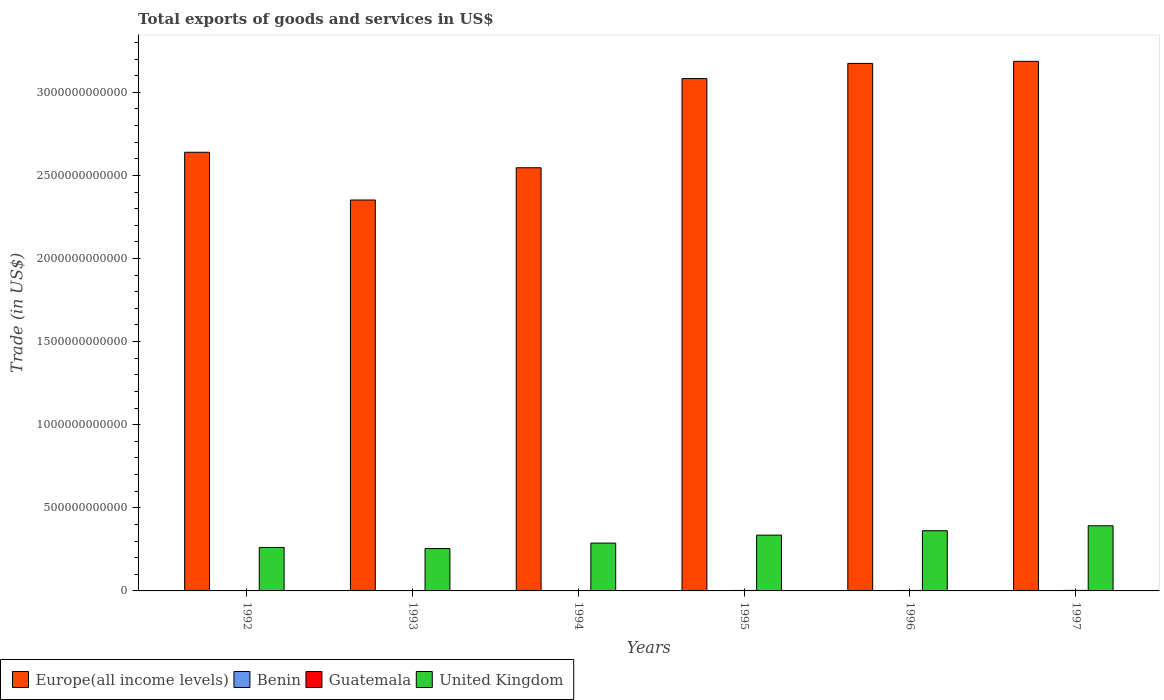How many different coloured bars are there?
Give a very brief answer. 4. How many groups of bars are there?
Provide a short and direct response. 6. Are the number of bars per tick equal to the number of legend labels?
Give a very brief answer. Yes. How many bars are there on the 4th tick from the left?
Offer a terse response. 4. How many bars are there on the 6th tick from the right?
Ensure brevity in your answer.  4. What is the label of the 6th group of bars from the left?
Ensure brevity in your answer.  1997. In how many cases, is the number of bars for a given year not equal to the number of legend labels?
Your response must be concise. 0. What is the total exports of goods and services in United Kingdom in 1995?
Your answer should be very brief. 3.36e+11. Across all years, what is the maximum total exports of goods and services in Benin?
Make the answer very short. 6.26e+08. Across all years, what is the minimum total exports of goods and services in United Kingdom?
Your answer should be compact. 2.55e+11. What is the total total exports of goods and services in Benin in the graph?
Your answer should be compact. 3.19e+09. What is the difference between the total exports of goods and services in Guatemala in 1992 and that in 1994?
Your answer should be very brief. -3.88e+08. What is the difference between the total exports of goods and services in Guatemala in 1993 and the total exports of goods and services in United Kingdom in 1995?
Ensure brevity in your answer.  -3.34e+11. What is the average total exports of goods and services in Europe(all income levels) per year?
Ensure brevity in your answer.  2.83e+12. In the year 1996, what is the difference between the total exports of goods and services in United Kingdom and total exports of goods and services in Europe(all income levels)?
Make the answer very short. -2.81e+12. What is the ratio of the total exports of goods and services in United Kingdom in 1992 to that in 1996?
Offer a terse response. 0.72. Is the total exports of goods and services in Benin in 1995 less than that in 1997?
Keep it short and to the point. Yes. Is the difference between the total exports of goods and services in United Kingdom in 1992 and 1997 greater than the difference between the total exports of goods and services in Europe(all income levels) in 1992 and 1997?
Provide a short and direct response. Yes. What is the difference between the highest and the second highest total exports of goods and services in Benin?
Provide a succinct answer. 9.23e+06. What is the difference between the highest and the lowest total exports of goods and services in Benin?
Provide a short and direct response. 2.32e+08. In how many years, is the total exports of goods and services in Guatemala greater than the average total exports of goods and services in Guatemala taken over all years?
Keep it short and to the point. 3. Is the sum of the total exports of goods and services in Europe(all income levels) in 1992 and 1996 greater than the maximum total exports of goods and services in Benin across all years?
Offer a terse response. Yes. Is it the case that in every year, the sum of the total exports of goods and services in Europe(all income levels) and total exports of goods and services in United Kingdom is greater than the sum of total exports of goods and services in Guatemala and total exports of goods and services in Benin?
Your response must be concise. No. What does the 1st bar from the left in 1992 represents?
Offer a very short reply. Europe(all income levels). What does the 4th bar from the right in 1995 represents?
Provide a succinct answer. Europe(all income levels). Are all the bars in the graph horizontal?
Offer a terse response. No. What is the difference between two consecutive major ticks on the Y-axis?
Provide a short and direct response. 5.00e+11. Does the graph contain any zero values?
Offer a very short reply. No. Where does the legend appear in the graph?
Offer a very short reply. Bottom left. How many legend labels are there?
Give a very brief answer. 4. How are the legend labels stacked?
Keep it short and to the point. Horizontal. What is the title of the graph?
Provide a succinct answer. Total exports of goods and services in US$. What is the label or title of the X-axis?
Provide a short and direct response. Years. What is the label or title of the Y-axis?
Offer a very short reply. Trade (in US$). What is the Trade (in US$) of Europe(all income levels) in 1992?
Offer a very short reply. 2.64e+12. What is the Trade (in US$) in Benin in 1992?
Your answer should be very brief. 3.94e+08. What is the Trade (in US$) in Guatemala in 1992?
Provide a succinct answer. 1.89e+09. What is the Trade (in US$) of United Kingdom in 1992?
Your answer should be very brief. 2.62e+11. What is the Trade (in US$) in Europe(all income levels) in 1993?
Provide a succinct answer. 2.35e+12. What is the Trade (in US$) of Benin in 1993?
Provide a short and direct response. 5.11e+08. What is the Trade (in US$) in Guatemala in 1993?
Keep it short and to the point. 2.02e+09. What is the Trade (in US$) in United Kingdom in 1993?
Keep it short and to the point. 2.55e+11. What is the Trade (in US$) of Europe(all income levels) in 1994?
Ensure brevity in your answer.  2.55e+12. What is the Trade (in US$) in Benin in 1994?
Provide a short and direct response. 4.53e+08. What is the Trade (in US$) in Guatemala in 1994?
Give a very brief answer. 2.27e+09. What is the Trade (in US$) of United Kingdom in 1994?
Ensure brevity in your answer.  2.88e+11. What is the Trade (in US$) in Europe(all income levels) in 1995?
Offer a very short reply. 3.08e+12. What is the Trade (in US$) in Benin in 1995?
Give a very brief answer. 5.94e+08. What is the Trade (in US$) in Guatemala in 1995?
Make the answer very short. 2.82e+09. What is the Trade (in US$) in United Kingdom in 1995?
Your answer should be very brief. 3.36e+11. What is the Trade (in US$) in Europe(all income levels) in 1996?
Your answer should be very brief. 3.17e+12. What is the Trade (in US$) in Benin in 1996?
Keep it short and to the point. 6.26e+08. What is the Trade (in US$) of Guatemala in 1996?
Your response must be concise. 2.81e+09. What is the Trade (in US$) of United Kingdom in 1996?
Give a very brief answer. 3.62e+11. What is the Trade (in US$) in Europe(all income levels) in 1997?
Offer a very short reply. 3.19e+12. What is the Trade (in US$) in Benin in 1997?
Your answer should be compact. 6.16e+08. What is the Trade (in US$) in Guatemala in 1997?
Make the answer very short. 3.19e+09. What is the Trade (in US$) in United Kingdom in 1997?
Your response must be concise. 3.92e+11. Across all years, what is the maximum Trade (in US$) of Europe(all income levels)?
Keep it short and to the point. 3.19e+12. Across all years, what is the maximum Trade (in US$) of Benin?
Make the answer very short. 6.26e+08. Across all years, what is the maximum Trade (in US$) of Guatemala?
Your answer should be compact. 3.19e+09. Across all years, what is the maximum Trade (in US$) in United Kingdom?
Your answer should be very brief. 3.92e+11. Across all years, what is the minimum Trade (in US$) of Europe(all income levels)?
Your response must be concise. 2.35e+12. Across all years, what is the minimum Trade (in US$) of Benin?
Your answer should be very brief. 3.94e+08. Across all years, what is the minimum Trade (in US$) in Guatemala?
Keep it short and to the point. 1.89e+09. Across all years, what is the minimum Trade (in US$) in United Kingdom?
Your answer should be compact. 2.55e+11. What is the total Trade (in US$) of Europe(all income levels) in the graph?
Offer a very short reply. 1.70e+13. What is the total Trade (in US$) in Benin in the graph?
Provide a succinct answer. 3.19e+09. What is the total Trade (in US$) in Guatemala in the graph?
Offer a terse response. 1.50e+1. What is the total Trade (in US$) in United Kingdom in the graph?
Offer a very short reply. 1.89e+12. What is the difference between the Trade (in US$) in Europe(all income levels) in 1992 and that in 1993?
Provide a short and direct response. 2.87e+11. What is the difference between the Trade (in US$) of Benin in 1992 and that in 1993?
Keep it short and to the point. -1.17e+08. What is the difference between the Trade (in US$) in Guatemala in 1992 and that in 1993?
Give a very brief answer. -1.32e+08. What is the difference between the Trade (in US$) of United Kingdom in 1992 and that in 1993?
Offer a terse response. 6.63e+09. What is the difference between the Trade (in US$) of Europe(all income levels) in 1992 and that in 1994?
Ensure brevity in your answer.  9.32e+1. What is the difference between the Trade (in US$) of Benin in 1992 and that in 1994?
Offer a very short reply. -5.87e+07. What is the difference between the Trade (in US$) in Guatemala in 1992 and that in 1994?
Your answer should be compact. -3.88e+08. What is the difference between the Trade (in US$) of United Kingdom in 1992 and that in 1994?
Give a very brief answer. -2.61e+1. What is the difference between the Trade (in US$) of Europe(all income levels) in 1992 and that in 1995?
Your answer should be very brief. -4.43e+11. What is the difference between the Trade (in US$) in Benin in 1992 and that in 1995?
Your answer should be very brief. -2.00e+08. What is the difference between the Trade (in US$) of Guatemala in 1992 and that in 1995?
Make the answer very short. -9.37e+08. What is the difference between the Trade (in US$) in United Kingdom in 1992 and that in 1995?
Your response must be concise. -7.41e+1. What is the difference between the Trade (in US$) in Europe(all income levels) in 1992 and that in 1996?
Make the answer very short. -5.35e+11. What is the difference between the Trade (in US$) in Benin in 1992 and that in 1996?
Offer a terse response. -2.32e+08. What is the difference between the Trade (in US$) of Guatemala in 1992 and that in 1996?
Keep it short and to the point. -9.24e+08. What is the difference between the Trade (in US$) of United Kingdom in 1992 and that in 1996?
Your answer should be compact. -1.01e+11. What is the difference between the Trade (in US$) of Europe(all income levels) in 1992 and that in 1997?
Ensure brevity in your answer.  -5.47e+11. What is the difference between the Trade (in US$) in Benin in 1992 and that in 1997?
Provide a succinct answer. -2.22e+08. What is the difference between the Trade (in US$) in Guatemala in 1992 and that in 1997?
Ensure brevity in your answer.  -1.31e+09. What is the difference between the Trade (in US$) in United Kingdom in 1992 and that in 1997?
Your answer should be compact. -1.30e+11. What is the difference between the Trade (in US$) of Europe(all income levels) in 1993 and that in 1994?
Ensure brevity in your answer.  -1.94e+11. What is the difference between the Trade (in US$) in Benin in 1993 and that in 1994?
Provide a succinct answer. 5.83e+07. What is the difference between the Trade (in US$) of Guatemala in 1993 and that in 1994?
Offer a terse response. -2.57e+08. What is the difference between the Trade (in US$) of United Kingdom in 1993 and that in 1994?
Your answer should be compact. -3.27e+1. What is the difference between the Trade (in US$) in Europe(all income levels) in 1993 and that in 1995?
Give a very brief answer. -7.31e+11. What is the difference between the Trade (in US$) of Benin in 1993 and that in 1995?
Make the answer very short. -8.28e+07. What is the difference between the Trade (in US$) in Guatemala in 1993 and that in 1995?
Ensure brevity in your answer.  -8.05e+08. What is the difference between the Trade (in US$) of United Kingdom in 1993 and that in 1995?
Provide a short and direct response. -8.07e+1. What is the difference between the Trade (in US$) of Europe(all income levels) in 1993 and that in 1996?
Ensure brevity in your answer.  -8.22e+11. What is the difference between the Trade (in US$) of Benin in 1993 and that in 1996?
Your answer should be very brief. -1.15e+08. What is the difference between the Trade (in US$) of Guatemala in 1993 and that in 1996?
Ensure brevity in your answer.  -7.93e+08. What is the difference between the Trade (in US$) of United Kingdom in 1993 and that in 1996?
Your answer should be very brief. -1.07e+11. What is the difference between the Trade (in US$) of Europe(all income levels) in 1993 and that in 1997?
Your response must be concise. -8.34e+11. What is the difference between the Trade (in US$) of Benin in 1993 and that in 1997?
Offer a very short reply. -1.05e+08. What is the difference between the Trade (in US$) of Guatemala in 1993 and that in 1997?
Provide a short and direct response. -1.18e+09. What is the difference between the Trade (in US$) of United Kingdom in 1993 and that in 1997?
Your answer should be compact. -1.37e+11. What is the difference between the Trade (in US$) in Europe(all income levels) in 1994 and that in 1995?
Provide a short and direct response. -5.37e+11. What is the difference between the Trade (in US$) of Benin in 1994 and that in 1995?
Provide a short and direct response. -1.41e+08. What is the difference between the Trade (in US$) in Guatemala in 1994 and that in 1995?
Make the answer very short. -5.48e+08. What is the difference between the Trade (in US$) of United Kingdom in 1994 and that in 1995?
Make the answer very short. -4.80e+1. What is the difference between the Trade (in US$) of Europe(all income levels) in 1994 and that in 1996?
Your answer should be compact. -6.28e+11. What is the difference between the Trade (in US$) in Benin in 1994 and that in 1996?
Offer a very short reply. -1.73e+08. What is the difference between the Trade (in US$) in Guatemala in 1994 and that in 1996?
Provide a short and direct response. -5.36e+08. What is the difference between the Trade (in US$) of United Kingdom in 1994 and that in 1996?
Your answer should be compact. -7.46e+1. What is the difference between the Trade (in US$) of Europe(all income levels) in 1994 and that in 1997?
Offer a very short reply. -6.40e+11. What is the difference between the Trade (in US$) in Benin in 1994 and that in 1997?
Your answer should be very brief. -1.64e+08. What is the difference between the Trade (in US$) of Guatemala in 1994 and that in 1997?
Provide a short and direct response. -9.19e+08. What is the difference between the Trade (in US$) of United Kingdom in 1994 and that in 1997?
Keep it short and to the point. -1.04e+11. What is the difference between the Trade (in US$) of Europe(all income levels) in 1995 and that in 1996?
Ensure brevity in your answer.  -9.12e+1. What is the difference between the Trade (in US$) of Benin in 1995 and that in 1996?
Offer a very short reply. -3.19e+07. What is the difference between the Trade (in US$) in Guatemala in 1995 and that in 1996?
Your response must be concise. 1.21e+07. What is the difference between the Trade (in US$) of United Kingdom in 1995 and that in 1996?
Ensure brevity in your answer.  -2.66e+1. What is the difference between the Trade (in US$) of Europe(all income levels) in 1995 and that in 1997?
Provide a succinct answer. -1.04e+11. What is the difference between the Trade (in US$) in Benin in 1995 and that in 1997?
Offer a very short reply. -2.26e+07. What is the difference between the Trade (in US$) in Guatemala in 1995 and that in 1997?
Your answer should be very brief. -3.71e+08. What is the difference between the Trade (in US$) of United Kingdom in 1995 and that in 1997?
Your response must be concise. -5.63e+1. What is the difference between the Trade (in US$) of Europe(all income levels) in 1996 and that in 1997?
Make the answer very short. -1.24e+1. What is the difference between the Trade (in US$) in Benin in 1996 and that in 1997?
Offer a terse response. 9.23e+06. What is the difference between the Trade (in US$) in Guatemala in 1996 and that in 1997?
Provide a short and direct response. -3.83e+08. What is the difference between the Trade (in US$) of United Kingdom in 1996 and that in 1997?
Keep it short and to the point. -2.97e+1. What is the difference between the Trade (in US$) of Europe(all income levels) in 1992 and the Trade (in US$) of Benin in 1993?
Make the answer very short. 2.64e+12. What is the difference between the Trade (in US$) in Europe(all income levels) in 1992 and the Trade (in US$) in Guatemala in 1993?
Your answer should be very brief. 2.64e+12. What is the difference between the Trade (in US$) of Europe(all income levels) in 1992 and the Trade (in US$) of United Kingdom in 1993?
Offer a very short reply. 2.38e+12. What is the difference between the Trade (in US$) of Benin in 1992 and the Trade (in US$) of Guatemala in 1993?
Give a very brief answer. -1.62e+09. What is the difference between the Trade (in US$) of Benin in 1992 and the Trade (in US$) of United Kingdom in 1993?
Keep it short and to the point. -2.55e+11. What is the difference between the Trade (in US$) of Guatemala in 1992 and the Trade (in US$) of United Kingdom in 1993?
Your answer should be very brief. -2.53e+11. What is the difference between the Trade (in US$) in Europe(all income levels) in 1992 and the Trade (in US$) in Benin in 1994?
Make the answer very short. 2.64e+12. What is the difference between the Trade (in US$) of Europe(all income levels) in 1992 and the Trade (in US$) of Guatemala in 1994?
Make the answer very short. 2.64e+12. What is the difference between the Trade (in US$) in Europe(all income levels) in 1992 and the Trade (in US$) in United Kingdom in 1994?
Give a very brief answer. 2.35e+12. What is the difference between the Trade (in US$) of Benin in 1992 and the Trade (in US$) of Guatemala in 1994?
Offer a very short reply. -1.88e+09. What is the difference between the Trade (in US$) in Benin in 1992 and the Trade (in US$) in United Kingdom in 1994?
Keep it short and to the point. -2.87e+11. What is the difference between the Trade (in US$) of Guatemala in 1992 and the Trade (in US$) of United Kingdom in 1994?
Make the answer very short. -2.86e+11. What is the difference between the Trade (in US$) in Europe(all income levels) in 1992 and the Trade (in US$) in Benin in 1995?
Provide a short and direct response. 2.64e+12. What is the difference between the Trade (in US$) in Europe(all income levels) in 1992 and the Trade (in US$) in Guatemala in 1995?
Offer a terse response. 2.64e+12. What is the difference between the Trade (in US$) of Europe(all income levels) in 1992 and the Trade (in US$) of United Kingdom in 1995?
Your answer should be compact. 2.30e+12. What is the difference between the Trade (in US$) of Benin in 1992 and the Trade (in US$) of Guatemala in 1995?
Your answer should be very brief. -2.43e+09. What is the difference between the Trade (in US$) in Benin in 1992 and the Trade (in US$) in United Kingdom in 1995?
Offer a very short reply. -3.35e+11. What is the difference between the Trade (in US$) in Guatemala in 1992 and the Trade (in US$) in United Kingdom in 1995?
Provide a succinct answer. -3.34e+11. What is the difference between the Trade (in US$) of Europe(all income levels) in 1992 and the Trade (in US$) of Benin in 1996?
Give a very brief answer. 2.64e+12. What is the difference between the Trade (in US$) of Europe(all income levels) in 1992 and the Trade (in US$) of Guatemala in 1996?
Offer a terse response. 2.64e+12. What is the difference between the Trade (in US$) in Europe(all income levels) in 1992 and the Trade (in US$) in United Kingdom in 1996?
Your answer should be compact. 2.28e+12. What is the difference between the Trade (in US$) in Benin in 1992 and the Trade (in US$) in Guatemala in 1996?
Make the answer very short. -2.42e+09. What is the difference between the Trade (in US$) in Benin in 1992 and the Trade (in US$) in United Kingdom in 1996?
Make the answer very short. -3.62e+11. What is the difference between the Trade (in US$) in Guatemala in 1992 and the Trade (in US$) in United Kingdom in 1996?
Provide a succinct answer. -3.60e+11. What is the difference between the Trade (in US$) of Europe(all income levels) in 1992 and the Trade (in US$) of Benin in 1997?
Provide a succinct answer. 2.64e+12. What is the difference between the Trade (in US$) of Europe(all income levels) in 1992 and the Trade (in US$) of Guatemala in 1997?
Your answer should be compact. 2.64e+12. What is the difference between the Trade (in US$) of Europe(all income levels) in 1992 and the Trade (in US$) of United Kingdom in 1997?
Give a very brief answer. 2.25e+12. What is the difference between the Trade (in US$) in Benin in 1992 and the Trade (in US$) in Guatemala in 1997?
Ensure brevity in your answer.  -2.80e+09. What is the difference between the Trade (in US$) in Benin in 1992 and the Trade (in US$) in United Kingdom in 1997?
Your answer should be very brief. -3.92e+11. What is the difference between the Trade (in US$) of Guatemala in 1992 and the Trade (in US$) of United Kingdom in 1997?
Offer a terse response. -3.90e+11. What is the difference between the Trade (in US$) in Europe(all income levels) in 1993 and the Trade (in US$) in Benin in 1994?
Offer a very short reply. 2.35e+12. What is the difference between the Trade (in US$) of Europe(all income levels) in 1993 and the Trade (in US$) of Guatemala in 1994?
Keep it short and to the point. 2.35e+12. What is the difference between the Trade (in US$) of Europe(all income levels) in 1993 and the Trade (in US$) of United Kingdom in 1994?
Provide a succinct answer. 2.06e+12. What is the difference between the Trade (in US$) in Benin in 1993 and the Trade (in US$) in Guatemala in 1994?
Provide a succinct answer. -1.76e+09. What is the difference between the Trade (in US$) of Benin in 1993 and the Trade (in US$) of United Kingdom in 1994?
Your answer should be compact. -2.87e+11. What is the difference between the Trade (in US$) in Guatemala in 1993 and the Trade (in US$) in United Kingdom in 1994?
Your answer should be compact. -2.86e+11. What is the difference between the Trade (in US$) in Europe(all income levels) in 1993 and the Trade (in US$) in Benin in 1995?
Provide a short and direct response. 2.35e+12. What is the difference between the Trade (in US$) in Europe(all income levels) in 1993 and the Trade (in US$) in Guatemala in 1995?
Provide a short and direct response. 2.35e+12. What is the difference between the Trade (in US$) in Europe(all income levels) in 1993 and the Trade (in US$) in United Kingdom in 1995?
Offer a terse response. 2.02e+12. What is the difference between the Trade (in US$) of Benin in 1993 and the Trade (in US$) of Guatemala in 1995?
Provide a succinct answer. -2.31e+09. What is the difference between the Trade (in US$) in Benin in 1993 and the Trade (in US$) in United Kingdom in 1995?
Your answer should be very brief. -3.35e+11. What is the difference between the Trade (in US$) in Guatemala in 1993 and the Trade (in US$) in United Kingdom in 1995?
Provide a short and direct response. -3.34e+11. What is the difference between the Trade (in US$) of Europe(all income levels) in 1993 and the Trade (in US$) of Benin in 1996?
Provide a short and direct response. 2.35e+12. What is the difference between the Trade (in US$) in Europe(all income levels) in 1993 and the Trade (in US$) in Guatemala in 1996?
Your answer should be compact. 2.35e+12. What is the difference between the Trade (in US$) of Europe(all income levels) in 1993 and the Trade (in US$) of United Kingdom in 1996?
Make the answer very short. 1.99e+12. What is the difference between the Trade (in US$) of Benin in 1993 and the Trade (in US$) of Guatemala in 1996?
Make the answer very short. -2.30e+09. What is the difference between the Trade (in US$) in Benin in 1993 and the Trade (in US$) in United Kingdom in 1996?
Ensure brevity in your answer.  -3.62e+11. What is the difference between the Trade (in US$) in Guatemala in 1993 and the Trade (in US$) in United Kingdom in 1996?
Ensure brevity in your answer.  -3.60e+11. What is the difference between the Trade (in US$) of Europe(all income levels) in 1993 and the Trade (in US$) of Benin in 1997?
Offer a very short reply. 2.35e+12. What is the difference between the Trade (in US$) of Europe(all income levels) in 1993 and the Trade (in US$) of Guatemala in 1997?
Provide a succinct answer. 2.35e+12. What is the difference between the Trade (in US$) of Europe(all income levels) in 1993 and the Trade (in US$) of United Kingdom in 1997?
Your answer should be compact. 1.96e+12. What is the difference between the Trade (in US$) in Benin in 1993 and the Trade (in US$) in Guatemala in 1997?
Give a very brief answer. -2.68e+09. What is the difference between the Trade (in US$) in Benin in 1993 and the Trade (in US$) in United Kingdom in 1997?
Give a very brief answer. -3.91e+11. What is the difference between the Trade (in US$) of Guatemala in 1993 and the Trade (in US$) of United Kingdom in 1997?
Keep it short and to the point. -3.90e+11. What is the difference between the Trade (in US$) in Europe(all income levels) in 1994 and the Trade (in US$) in Benin in 1995?
Your answer should be compact. 2.55e+12. What is the difference between the Trade (in US$) of Europe(all income levels) in 1994 and the Trade (in US$) of Guatemala in 1995?
Provide a succinct answer. 2.54e+12. What is the difference between the Trade (in US$) in Europe(all income levels) in 1994 and the Trade (in US$) in United Kingdom in 1995?
Your answer should be compact. 2.21e+12. What is the difference between the Trade (in US$) of Benin in 1994 and the Trade (in US$) of Guatemala in 1995?
Provide a succinct answer. -2.37e+09. What is the difference between the Trade (in US$) of Benin in 1994 and the Trade (in US$) of United Kingdom in 1995?
Your answer should be compact. -3.35e+11. What is the difference between the Trade (in US$) in Guatemala in 1994 and the Trade (in US$) in United Kingdom in 1995?
Provide a succinct answer. -3.33e+11. What is the difference between the Trade (in US$) of Europe(all income levels) in 1994 and the Trade (in US$) of Benin in 1996?
Your response must be concise. 2.55e+12. What is the difference between the Trade (in US$) in Europe(all income levels) in 1994 and the Trade (in US$) in Guatemala in 1996?
Your answer should be compact. 2.54e+12. What is the difference between the Trade (in US$) in Europe(all income levels) in 1994 and the Trade (in US$) in United Kingdom in 1996?
Provide a succinct answer. 2.18e+12. What is the difference between the Trade (in US$) in Benin in 1994 and the Trade (in US$) in Guatemala in 1996?
Keep it short and to the point. -2.36e+09. What is the difference between the Trade (in US$) of Benin in 1994 and the Trade (in US$) of United Kingdom in 1996?
Give a very brief answer. -3.62e+11. What is the difference between the Trade (in US$) of Guatemala in 1994 and the Trade (in US$) of United Kingdom in 1996?
Make the answer very short. -3.60e+11. What is the difference between the Trade (in US$) in Europe(all income levels) in 1994 and the Trade (in US$) in Benin in 1997?
Your answer should be very brief. 2.55e+12. What is the difference between the Trade (in US$) in Europe(all income levels) in 1994 and the Trade (in US$) in Guatemala in 1997?
Offer a very short reply. 2.54e+12. What is the difference between the Trade (in US$) of Europe(all income levels) in 1994 and the Trade (in US$) of United Kingdom in 1997?
Provide a succinct answer. 2.15e+12. What is the difference between the Trade (in US$) of Benin in 1994 and the Trade (in US$) of Guatemala in 1997?
Give a very brief answer. -2.74e+09. What is the difference between the Trade (in US$) in Benin in 1994 and the Trade (in US$) in United Kingdom in 1997?
Provide a short and direct response. -3.92e+11. What is the difference between the Trade (in US$) of Guatemala in 1994 and the Trade (in US$) of United Kingdom in 1997?
Make the answer very short. -3.90e+11. What is the difference between the Trade (in US$) in Europe(all income levels) in 1995 and the Trade (in US$) in Benin in 1996?
Make the answer very short. 3.08e+12. What is the difference between the Trade (in US$) of Europe(all income levels) in 1995 and the Trade (in US$) of Guatemala in 1996?
Offer a terse response. 3.08e+12. What is the difference between the Trade (in US$) in Europe(all income levels) in 1995 and the Trade (in US$) in United Kingdom in 1996?
Give a very brief answer. 2.72e+12. What is the difference between the Trade (in US$) of Benin in 1995 and the Trade (in US$) of Guatemala in 1996?
Offer a very short reply. -2.22e+09. What is the difference between the Trade (in US$) in Benin in 1995 and the Trade (in US$) in United Kingdom in 1996?
Ensure brevity in your answer.  -3.62e+11. What is the difference between the Trade (in US$) of Guatemala in 1995 and the Trade (in US$) of United Kingdom in 1996?
Give a very brief answer. -3.59e+11. What is the difference between the Trade (in US$) in Europe(all income levels) in 1995 and the Trade (in US$) in Benin in 1997?
Your answer should be compact. 3.08e+12. What is the difference between the Trade (in US$) of Europe(all income levels) in 1995 and the Trade (in US$) of Guatemala in 1997?
Your answer should be compact. 3.08e+12. What is the difference between the Trade (in US$) in Europe(all income levels) in 1995 and the Trade (in US$) in United Kingdom in 1997?
Make the answer very short. 2.69e+12. What is the difference between the Trade (in US$) in Benin in 1995 and the Trade (in US$) in Guatemala in 1997?
Make the answer very short. -2.60e+09. What is the difference between the Trade (in US$) of Benin in 1995 and the Trade (in US$) of United Kingdom in 1997?
Offer a terse response. -3.91e+11. What is the difference between the Trade (in US$) in Guatemala in 1995 and the Trade (in US$) in United Kingdom in 1997?
Keep it short and to the point. -3.89e+11. What is the difference between the Trade (in US$) of Europe(all income levels) in 1996 and the Trade (in US$) of Benin in 1997?
Provide a succinct answer. 3.17e+12. What is the difference between the Trade (in US$) of Europe(all income levels) in 1996 and the Trade (in US$) of Guatemala in 1997?
Your answer should be very brief. 3.17e+12. What is the difference between the Trade (in US$) in Europe(all income levels) in 1996 and the Trade (in US$) in United Kingdom in 1997?
Your answer should be compact. 2.78e+12. What is the difference between the Trade (in US$) of Benin in 1996 and the Trade (in US$) of Guatemala in 1997?
Your answer should be very brief. -2.57e+09. What is the difference between the Trade (in US$) of Benin in 1996 and the Trade (in US$) of United Kingdom in 1997?
Make the answer very short. -3.91e+11. What is the difference between the Trade (in US$) of Guatemala in 1996 and the Trade (in US$) of United Kingdom in 1997?
Offer a terse response. -3.89e+11. What is the average Trade (in US$) of Europe(all income levels) per year?
Keep it short and to the point. 2.83e+12. What is the average Trade (in US$) in Benin per year?
Ensure brevity in your answer.  5.32e+08. What is the average Trade (in US$) in Guatemala per year?
Provide a short and direct response. 2.50e+09. What is the average Trade (in US$) in United Kingdom per year?
Keep it short and to the point. 3.16e+11. In the year 1992, what is the difference between the Trade (in US$) of Europe(all income levels) and Trade (in US$) of Benin?
Your answer should be very brief. 2.64e+12. In the year 1992, what is the difference between the Trade (in US$) in Europe(all income levels) and Trade (in US$) in Guatemala?
Your response must be concise. 2.64e+12. In the year 1992, what is the difference between the Trade (in US$) in Europe(all income levels) and Trade (in US$) in United Kingdom?
Your answer should be compact. 2.38e+12. In the year 1992, what is the difference between the Trade (in US$) in Benin and Trade (in US$) in Guatemala?
Your response must be concise. -1.49e+09. In the year 1992, what is the difference between the Trade (in US$) in Benin and Trade (in US$) in United Kingdom?
Provide a succinct answer. -2.61e+11. In the year 1992, what is the difference between the Trade (in US$) of Guatemala and Trade (in US$) of United Kingdom?
Provide a succinct answer. -2.60e+11. In the year 1993, what is the difference between the Trade (in US$) in Europe(all income levels) and Trade (in US$) in Benin?
Offer a terse response. 2.35e+12. In the year 1993, what is the difference between the Trade (in US$) of Europe(all income levels) and Trade (in US$) of Guatemala?
Give a very brief answer. 2.35e+12. In the year 1993, what is the difference between the Trade (in US$) of Europe(all income levels) and Trade (in US$) of United Kingdom?
Provide a succinct answer. 2.10e+12. In the year 1993, what is the difference between the Trade (in US$) of Benin and Trade (in US$) of Guatemala?
Keep it short and to the point. -1.51e+09. In the year 1993, what is the difference between the Trade (in US$) of Benin and Trade (in US$) of United Kingdom?
Offer a terse response. -2.54e+11. In the year 1993, what is the difference between the Trade (in US$) of Guatemala and Trade (in US$) of United Kingdom?
Provide a succinct answer. -2.53e+11. In the year 1994, what is the difference between the Trade (in US$) in Europe(all income levels) and Trade (in US$) in Benin?
Ensure brevity in your answer.  2.55e+12. In the year 1994, what is the difference between the Trade (in US$) in Europe(all income levels) and Trade (in US$) in Guatemala?
Provide a succinct answer. 2.54e+12. In the year 1994, what is the difference between the Trade (in US$) of Europe(all income levels) and Trade (in US$) of United Kingdom?
Keep it short and to the point. 2.26e+12. In the year 1994, what is the difference between the Trade (in US$) of Benin and Trade (in US$) of Guatemala?
Your answer should be compact. -1.82e+09. In the year 1994, what is the difference between the Trade (in US$) of Benin and Trade (in US$) of United Kingdom?
Provide a short and direct response. -2.87e+11. In the year 1994, what is the difference between the Trade (in US$) of Guatemala and Trade (in US$) of United Kingdom?
Your answer should be very brief. -2.85e+11. In the year 1995, what is the difference between the Trade (in US$) in Europe(all income levels) and Trade (in US$) in Benin?
Offer a terse response. 3.08e+12. In the year 1995, what is the difference between the Trade (in US$) of Europe(all income levels) and Trade (in US$) of Guatemala?
Offer a very short reply. 3.08e+12. In the year 1995, what is the difference between the Trade (in US$) in Europe(all income levels) and Trade (in US$) in United Kingdom?
Offer a very short reply. 2.75e+12. In the year 1995, what is the difference between the Trade (in US$) of Benin and Trade (in US$) of Guatemala?
Give a very brief answer. -2.23e+09. In the year 1995, what is the difference between the Trade (in US$) in Benin and Trade (in US$) in United Kingdom?
Your answer should be compact. -3.35e+11. In the year 1995, what is the difference between the Trade (in US$) of Guatemala and Trade (in US$) of United Kingdom?
Provide a short and direct response. -3.33e+11. In the year 1996, what is the difference between the Trade (in US$) in Europe(all income levels) and Trade (in US$) in Benin?
Provide a short and direct response. 3.17e+12. In the year 1996, what is the difference between the Trade (in US$) of Europe(all income levels) and Trade (in US$) of Guatemala?
Your answer should be very brief. 3.17e+12. In the year 1996, what is the difference between the Trade (in US$) in Europe(all income levels) and Trade (in US$) in United Kingdom?
Ensure brevity in your answer.  2.81e+12. In the year 1996, what is the difference between the Trade (in US$) of Benin and Trade (in US$) of Guatemala?
Your answer should be very brief. -2.19e+09. In the year 1996, what is the difference between the Trade (in US$) of Benin and Trade (in US$) of United Kingdom?
Your answer should be very brief. -3.62e+11. In the year 1996, what is the difference between the Trade (in US$) of Guatemala and Trade (in US$) of United Kingdom?
Make the answer very short. -3.59e+11. In the year 1997, what is the difference between the Trade (in US$) in Europe(all income levels) and Trade (in US$) in Benin?
Provide a short and direct response. 3.19e+12. In the year 1997, what is the difference between the Trade (in US$) in Europe(all income levels) and Trade (in US$) in Guatemala?
Your answer should be very brief. 3.18e+12. In the year 1997, what is the difference between the Trade (in US$) of Europe(all income levels) and Trade (in US$) of United Kingdom?
Make the answer very short. 2.79e+12. In the year 1997, what is the difference between the Trade (in US$) of Benin and Trade (in US$) of Guatemala?
Offer a very short reply. -2.58e+09. In the year 1997, what is the difference between the Trade (in US$) of Benin and Trade (in US$) of United Kingdom?
Offer a very short reply. -3.91e+11. In the year 1997, what is the difference between the Trade (in US$) of Guatemala and Trade (in US$) of United Kingdom?
Provide a short and direct response. -3.89e+11. What is the ratio of the Trade (in US$) of Europe(all income levels) in 1992 to that in 1993?
Ensure brevity in your answer.  1.12. What is the ratio of the Trade (in US$) in Benin in 1992 to that in 1993?
Give a very brief answer. 0.77. What is the ratio of the Trade (in US$) in Guatemala in 1992 to that in 1993?
Offer a terse response. 0.93. What is the ratio of the Trade (in US$) in Europe(all income levels) in 1992 to that in 1994?
Ensure brevity in your answer.  1.04. What is the ratio of the Trade (in US$) of Benin in 1992 to that in 1994?
Your answer should be compact. 0.87. What is the ratio of the Trade (in US$) of Guatemala in 1992 to that in 1994?
Provide a short and direct response. 0.83. What is the ratio of the Trade (in US$) in United Kingdom in 1992 to that in 1994?
Offer a very short reply. 0.91. What is the ratio of the Trade (in US$) in Europe(all income levels) in 1992 to that in 1995?
Ensure brevity in your answer.  0.86. What is the ratio of the Trade (in US$) of Benin in 1992 to that in 1995?
Make the answer very short. 0.66. What is the ratio of the Trade (in US$) of Guatemala in 1992 to that in 1995?
Offer a very short reply. 0.67. What is the ratio of the Trade (in US$) in United Kingdom in 1992 to that in 1995?
Give a very brief answer. 0.78. What is the ratio of the Trade (in US$) in Europe(all income levels) in 1992 to that in 1996?
Ensure brevity in your answer.  0.83. What is the ratio of the Trade (in US$) in Benin in 1992 to that in 1996?
Provide a succinct answer. 0.63. What is the ratio of the Trade (in US$) in Guatemala in 1992 to that in 1996?
Offer a very short reply. 0.67. What is the ratio of the Trade (in US$) of United Kingdom in 1992 to that in 1996?
Offer a terse response. 0.72. What is the ratio of the Trade (in US$) of Europe(all income levels) in 1992 to that in 1997?
Give a very brief answer. 0.83. What is the ratio of the Trade (in US$) in Benin in 1992 to that in 1997?
Your response must be concise. 0.64. What is the ratio of the Trade (in US$) in Guatemala in 1992 to that in 1997?
Your answer should be very brief. 0.59. What is the ratio of the Trade (in US$) in United Kingdom in 1992 to that in 1997?
Give a very brief answer. 0.67. What is the ratio of the Trade (in US$) of Europe(all income levels) in 1993 to that in 1994?
Your answer should be compact. 0.92. What is the ratio of the Trade (in US$) of Benin in 1993 to that in 1994?
Your response must be concise. 1.13. What is the ratio of the Trade (in US$) of Guatemala in 1993 to that in 1994?
Provide a succinct answer. 0.89. What is the ratio of the Trade (in US$) in United Kingdom in 1993 to that in 1994?
Give a very brief answer. 0.89. What is the ratio of the Trade (in US$) in Europe(all income levels) in 1993 to that in 1995?
Offer a terse response. 0.76. What is the ratio of the Trade (in US$) of Benin in 1993 to that in 1995?
Keep it short and to the point. 0.86. What is the ratio of the Trade (in US$) in Guatemala in 1993 to that in 1995?
Keep it short and to the point. 0.71. What is the ratio of the Trade (in US$) in United Kingdom in 1993 to that in 1995?
Make the answer very short. 0.76. What is the ratio of the Trade (in US$) of Europe(all income levels) in 1993 to that in 1996?
Give a very brief answer. 0.74. What is the ratio of the Trade (in US$) in Benin in 1993 to that in 1996?
Ensure brevity in your answer.  0.82. What is the ratio of the Trade (in US$) of Guatemala in 1993 to that in 1996?
Your response must be concise. 0.72. What is the ratio of the Trade (in US$) of United Kingdom in 1993 to that in 1996?
Give a very brief answer. 0.7. What is the ratio of the Trade (in US$) of Europe(all income levels) in 1993 to that in 1997?
Offer a terse response. 0.74. What is the ratio of the Trade (in US$) of Benin in 1993 to that in 1997?
Your answer should be compact. 0.83. What is the ratio of the Trade (in US$) of Guatemala in 1993 to that in 1997?
Provide a short and direct response. 0.63. What is the ratio of the Trade (in US$) of United Kingdom in 1993 to that in 1997?
Give a very brief answer. 0.65. What is the ratio of the Trade (in US$) in Europe(all income levels) in 1994 to that in 1995?
Make the answer very short. 0.83. What is the ratio of the Trade (in US$) of Benin in 1994 to that in 1995?
Ensure brevity in your answer.  0.76. What is the ratio of the Trade (in US$) in Guatemala in 1994 to that in 1995?
Keep it short and to the point. 0.81. What is the ratio of the Trade (in US$) of United Kingdom in 1994 to that in 1995?
Your answer should be very brief. 0.86. What is the ratio of the Trade (in US$) in Europe(all income levels) in 1994 to that in 1996?
Provide a succinct answer. 0.8. What is the ratio of the Trade (in US$) of Benin in 1994 to that in 1996?
Your answer should be very brief. 0.72. What is the ratio of the Trade (in US$) in Guatemala in 1994 to that in 1996?
Offer a terse response. 0.81. What is the ratio of the Trade (in US$) in United Kingdom in 1994 to that in 1996?
Ensure brevity in your answer.  0.79. What is the ratio of the Trade (in US$) of Europe(all income levels) in 1994 to that in 1997?
Your answer should be very brief. 0.8. What is the ratio of the Trade (in US$) of Benin in 1994 to that in 1997?
Ensure brevity in your answer.  0.73. What is the ratio of the Trade (in US$) in Guatemala in 1994 to that in 1997?
Give a very brief answer. 0.71. What is the ratio of the Trade (in US$) in United Kingdom in 1994 to that in 1997?
Provide a succinct answer. 0.73. What is the ratio of the Trade (in US$) of Europe(all income levels) in 1995 to that in 1996?
Make the answer very short. 0.97. What is the ratio of the Trade (in US$) of Benin in 1995 to that in 1996?
Provide a short and direct response. 0.95. What is the ratio of the Trade (in US$) of Guatemala in 1995 to that in 1996?
Offer a terse response. 1. What is the ratio of the Trade (in US$) in United Kingdom in 1995 to that in 1996?
Your answer should be very brief. 0.93. What is the ratio of the Trade (in US$) in Europe(all income levels) in 1995 to that in 1997?
Give a very brief answer. 0.97. What is the ratio of the Trade (in US$) of Benin in 1995 to that in 1997?
Keep it short and to the point. 0.96. What is the ratio of the Trade (in US$) of Guatemala in 1995 to that in 1997?
Your response must be concise. 0.88. What is the ratio of the Trade (in US$) of United Kingdom in 1995 to that in 1997?
Offer a very short reply. 0.86. What is the ratio of the Trade (in US$) in Europe(all income levels) in 1996 to that in 1997?
Ensure brevity in your answer.  1. What is the ratio of the Trade (in US$) of Guatemala in 1996 to that in 1997?
Provide a succinct answer. 0.88. What is the ratio of the Trade (in US$) of United Kingdom in 1996 to that in 1997?
Provide a short and direct response. 0.92. What is the difference between the highest and the second highest Trade (in US$) in Europe(all income levels)?
Offer a terse response. 1.24e+1. What is the difference between the highest and the second highest Trade (in US$) of Benin?
Make the answer very short. 9.23e+06. What is the difference between the highest and the second highest Trade (in US$) in Guatemala?
Your answer should be compact. 3.71e+08. What is the difference between the highest and the second highest Trade (in US$) in United Kingdom?
Your response must be concise. 2.97e+1. What is the difference between the highest and the lowest Trade (in US$) of Europe(all income levels)?
Keep it short and to the point. 8.34e+11. What is the difference between the highest and the lowest Trade (in US$) in Benin?
Your response must be concise. 2.32e+08. What is the difference between the highest and the lowest Trade (in US$) in Guatemala?
Your answer should be very brief. 1.31e+09. What is the difference between the highest and the lowest Trade (in US$) of United Kingdom?
Your answer should be very brief. 1.37e+11. 